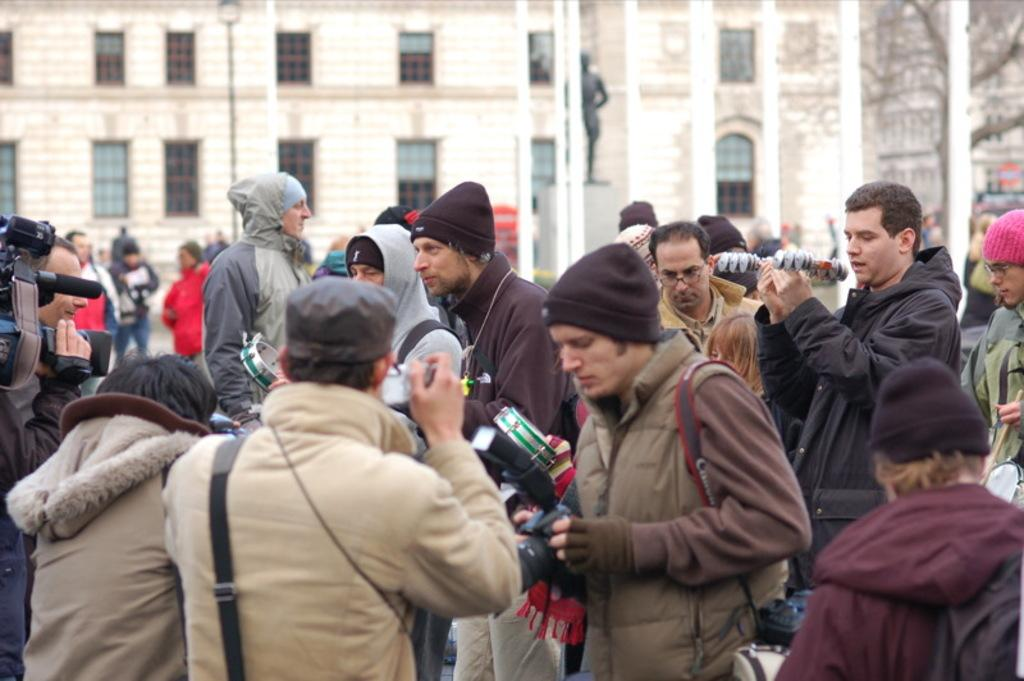How many people can be seen in the image? There are many persons on the ground in the image. What can be seen in the background of the image? There are poles, a statue, a building, and a tree in the background of the image. What grade of liquid is being used to clean the statue in the image? There is no indication in the image that the statue is being cleaned, nor is there any mention of liquid being used. 